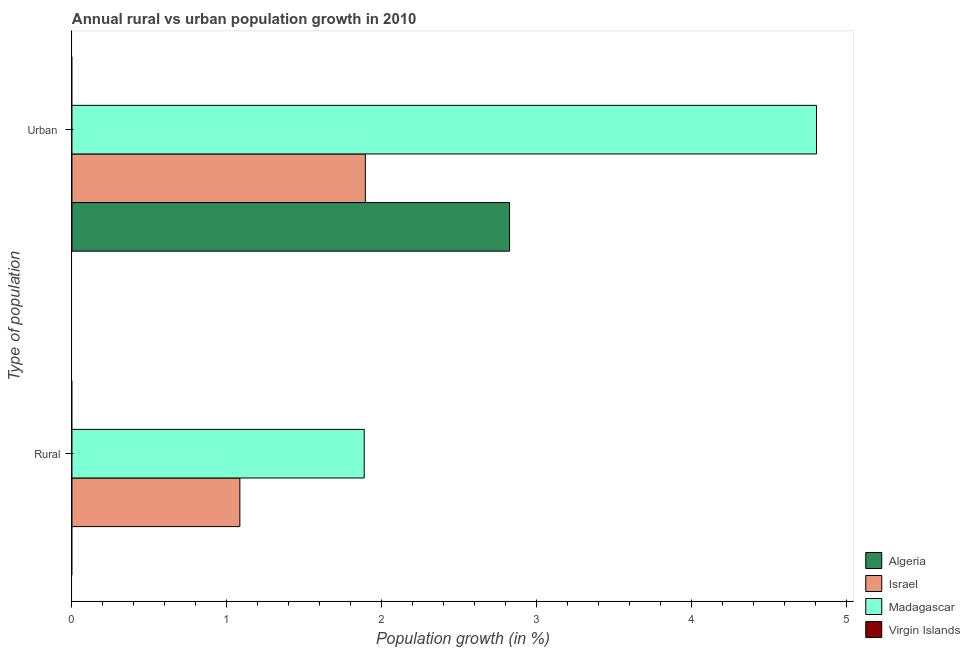Are the number of bars per tick equal to the number of legend labels?
Your answer should be compact. No. How many bars are there on the 2nd tick from the top?
Keep it short and to the point. 2. How many bars are there on the 1st tick from the bottom?
Make the answer very short. 2. What is the label of the 1st group of bars from the top?
Keep it short and to the point. Urban . What is the urban population growth in Algeria?
Ensure brevity in your answer.  2.82. Across all countries, what is the maximum rural population growth?
Give a very brief answer. 1.89. In which country was the urban population growth maximum?
Offer a very short reply. Madagascar. What is the total urban population growth in the graph?
Ensure brevity in your answer.  9.52. What is the difference between the urban population growth in Madagascar and that in Israel?
Provide a short and direct response. 2.91. What is the difference between the rural population growth in Virgin Islands and the urban population growth in Madagascar?
Your answer should be very brief. -4.8. What is the average rural population growth per country?
Keep it short and to the point. 0.74. What is the difference between the urban population growth and rural population growth in Israel?
Offer a very short reply. 0.81. In how many countries, is the rural population growth greater than 0.6000000000000001 %?
Provide a succinct answer. 2. What is the ratio of the rural population growth in Israel to that in Madagascar?
Your answer should be very brief. 0.57. Is the urban population growth in Algeria less than that in Madagascar?
Ensure brevity in your answer.  Yes. Are all the bars in the graph horizontal?
Keep it short and to the point. Yes. How many countries are there in the graph?
Make the answer very short. 4. Are the values on the major ticks of X-axis written in scientific E-notation?
Offer a terse response. No. Does the graph contain any zero values?
Your response must be concise. Yes. Does the graph contain grids?
Ensure brevity in your answer.  No. Where does the legend appear in the graph?
Ensure brevity in your answer.  Bottom right. How many legend labels are there?
Your response must be concise. 4. How are the legend labels stacked?
Offer a very short reply. Vertical. What is the title of the graph?
Your answer should be very brief. Annual rural vs urban population growth in 2010. What is the label or title of the X-axis?
Ensure brevity in your answer.  Population growth (in %). What is the label or title of the Y-axis?
Your answer should be very brief. Type of population. What is the Population growth (in %) in Israel in Rural?
Ensure brevity in your answer.  1.08. What is the Population growth (in %) of Madagascar in Rural?
Offer a very short reply. 1.89. What is the Population growth (in %) of Algeria in Urban ?
Keep it short and to the point. 2.82. What is the Population growth (in %) of Israel in Urban ?
Your answer should be very brief. 1.89. What is the Population growth (in %) in Madagascar in Urban ?
Give a very brief answer. 4.8. Across all Type of population, what is the maximum Population growth (in %) in Algeria?
Make the answer very short. 2.82. Across all Type of population, what is the maximum Population growth (in %) in Israel?
Give a very brief answer. 1.89. Across all Type of population, what is the maximum Population growth (in %) in Madagascar?
Make the answer very short. 4.8. Across all Type of population, what is the minimum Population growth (in %) of Israel?
Make the answer very short. 1.08. Across all Type of population, what is the minimum Population growth (in %) of Madagascar?
Make the answer very short. 1.89. What is the total Population growth (in %) in Algeria in the graph?
Your answer should be compact. 2.82. What is the total Population growth (in %) in Israel in the graph?
Keep it short and to the point. 2.98. What is the total Population growth (in %) in Madagascar in the graph?
Keep it short and to the point. 6.69. What is the total Population growth (in %) of Virgin Islands in the graph?
Ensure brevity in your answer.  0. What is the difference between the Population growth (in %) of Israel in Rural and that in Urban ?
Provide a succinct answer. -0.81. What is the difference between the Population growth (in %) of Madagascar in Rural and that in Urban ?
Keep it short and to the point. -2.92. What is the difference between the Population growth (in %) in Israel in Rural and the Population growth (in %) in Madagascar in Urban ?
Your answer should be very brief. -3.72. What is the average Population growth (in %) of Algeria per Type of population?
Your response must be concise. 1.41. What is the average Population growth (in %) of Israel per Type of population?
Ensure brevity in your answer.  1.49. What is the average Population growth (in %) of Madagascar per Type of population?
Provide a short and direct response. 3.35. What is the average Population growth (in %) in Virgin Islands per Type of population?
Provide a succinct answer. 0. What is the difference between the Population growth (in %) in Israel and Population growth (in %) in Madagascar in Rural?
Keep it short and to the point. -0.8. What is the difference between the Population growth (in %) of Algeria and Population growth (in %) of Israel in Urban ?
Offer a very short reply. 0.93. What is the difference between the Population growth (in %) in Algeria and Population growth (in %) in Madagascar in Urban ?
Your answer should be very brief. -1.98. What is the difference between the Population growth (in %) in Israel and Population growth (in %) in Madagascar in Urban ?
Offer a terse response. -2.91. What is the ratio of the Population growth (in %) of Israel in Rural to that in Urban ?
Give a very brief answer. 0.57. What is the ratio of the Population growth (in %) of Madagascar in Rural to that in Urban ?
Offer a terse response. 0.39. What is the difference between the highest and the second highest Population growth (in %) of Israel?
Offer a very short reply. 0.81. What is the difference between the highest and the second highest Population growth (in %) of Madagascar?
Your answer should be very brief. 2.92. What is the difference between the highest and the lowest Population growth (in %) of Algeria?
Keep it short and to the point. 2.82. What is the difference between the highest and the lowest Population growth (in %) in Israel?
Your answer should be compact. 0.81. What is the difference between the highest and the lowest Population growth (in %) of Madagascar?
Keep it short and to the point. 2.92. 